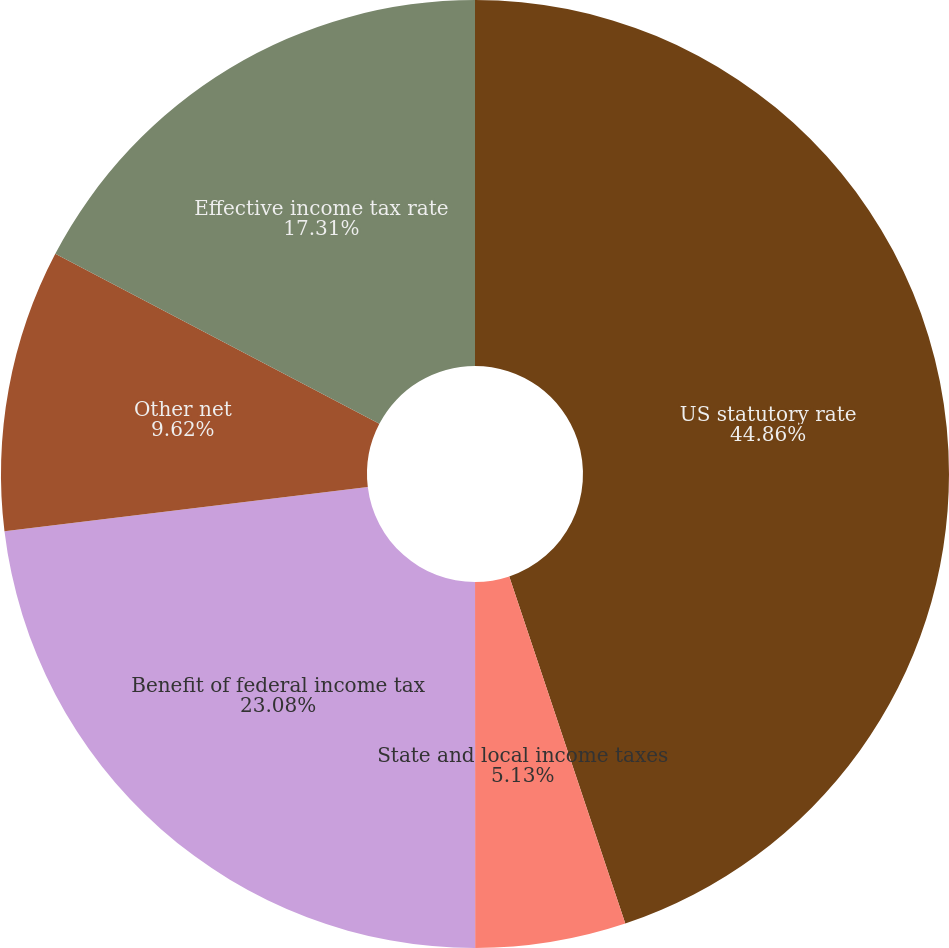Convert chart to OTSL. <chart><loc_0><loc_0><loc_500><loc_500><pie_chart><fcel>US statutory rate<fcel>State and local income taxes<fcel>Benefit of federal income tax<fcel>Other net<fcel>Effective income tax rate<nl><fcel>44.87%<fcel>5.13%<fcel>23.08%<fcel>9.62%<fcel>17.31%<nl></chart> 